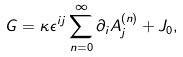<formula> <loc_0><loc_0><loc_500><loc_500>G = \kappa \epsilon ^ { i j } \sum _ { n = 0 } ^ { \infty } \partial _ { i } A _ { j } ^ { ( n ) } + J _ { 0 } ,</formula> 